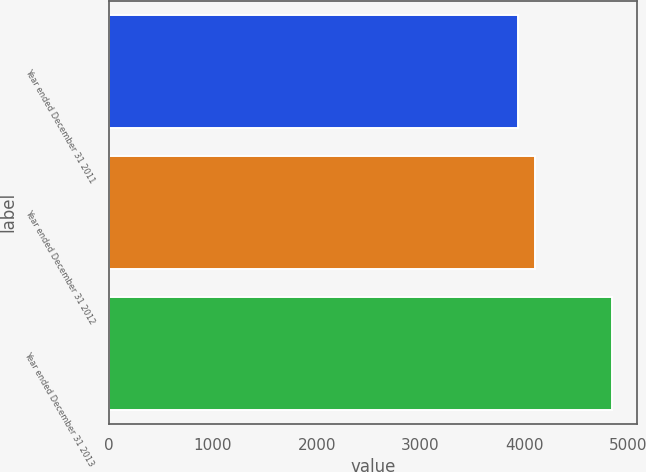Convert chart. <chart><loc_0><loc_0><loc_500><loc_500><bar_chart><fcel>Year ended December 31 2011<fcel>Year ended December 31 2012<fcel>Year ended December 31 2013<nl><fcel>3939<fcel>4106<fcel>4846<nl></chart> 